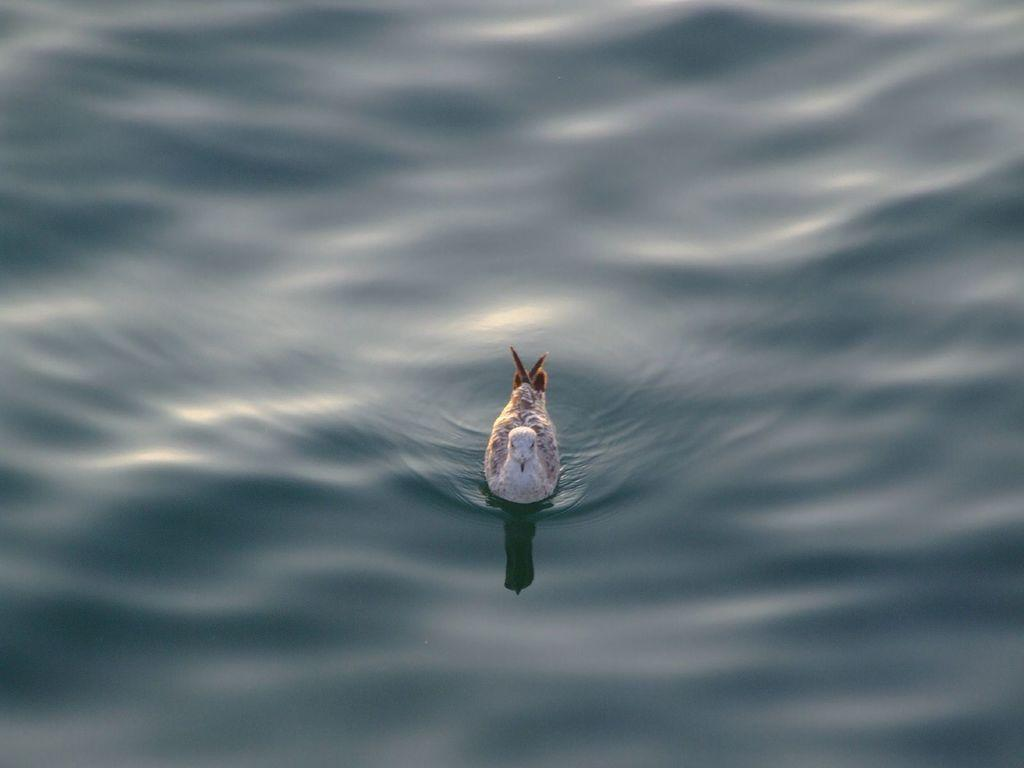What is present in the image that is not solid? There is water in the image. What type of animal can be seen in the image? There is a bird in the image. What is the water surface showing in the image? There is a reflection visible on the water. What color is the wren's shirt in the image? There is no wren or shirt present in the image. How many volleyballs are floating on the water in the image? There are no volleyballs present in the image. 